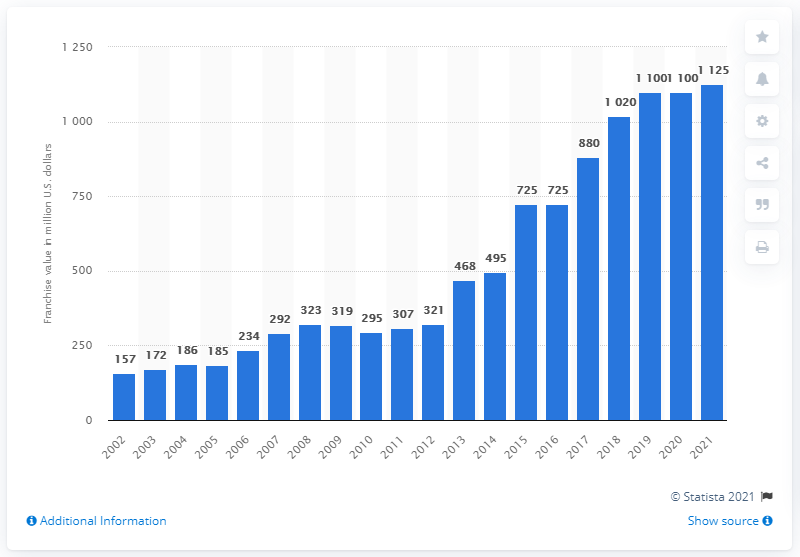Outline some significant characteristics in this image. According to estimates, the value of the Oakland Athletics in 2021 was approximately 1125. 